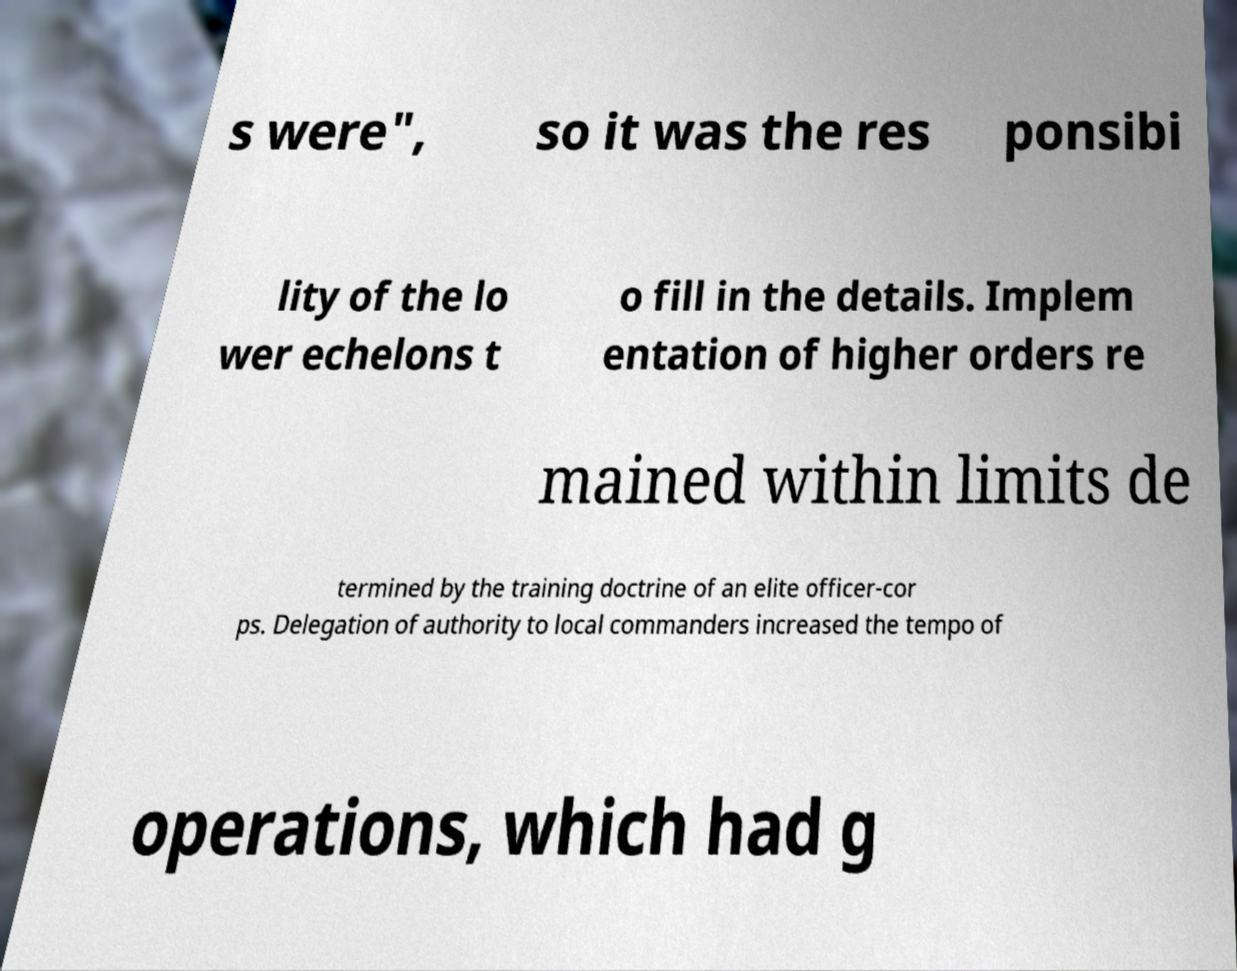Can you read and provide the text displayed in the image?This photo seems to have some interesting text. Can you extract and type it out for me? s were", so it was the res ponsibi lity of the lo wer echelons t o fill in the details. Implem entation of higher orders re mained within limits de termined by the training doctrine of an elite officer-cor ps. Delegation of authority to local commanders increased the tempo of operations, which had g 